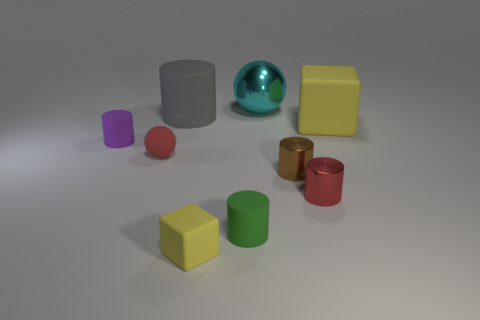There is a thing that is the same color as the matte sphere; what shape is it?
Give a very brief answer. Cylinder. Are there any small shiny cylinders of the same color as the tiny matte ball?
Offer a very short reply. Yes. Is the number of red cylinders greater than the number of large yellow metallic cylinders?
Offer a very short reply. Yes. What is the size of the matte object that is the same color as the small rubber block?
Ensure brevity in your answer.  Large. Are there any small red cylinders made of the same material as the gray cylinder?
Ensure brevity in your answer.  No. What shape is the tiny matte thing that is both left of the green cylinder and on the right side of the large gray cylinder?
Provide a short and direct response. Cube. How many other things are the same shape as the purple rubber object?
Your answer should be very brief. 4. What is the size of the shiny ball?
Offer a very short reply. Large. How many things are either small blue rubber blocks or large cyan spheres?
Offer a very short reply. 1. What is the size of the sphere that is behind the small purple cylinder?
Offer a terse response. Large. 